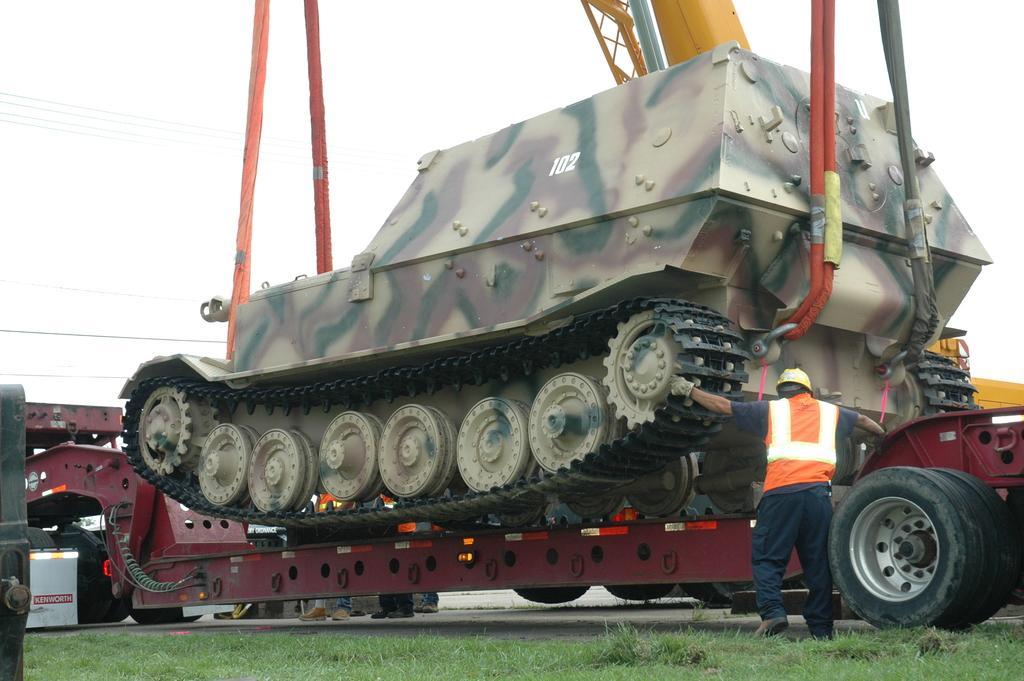Describe this image in one or two sentences. In this picture we can see a vehicle and some people standing on the road, grass and in the background we can see the sky. 